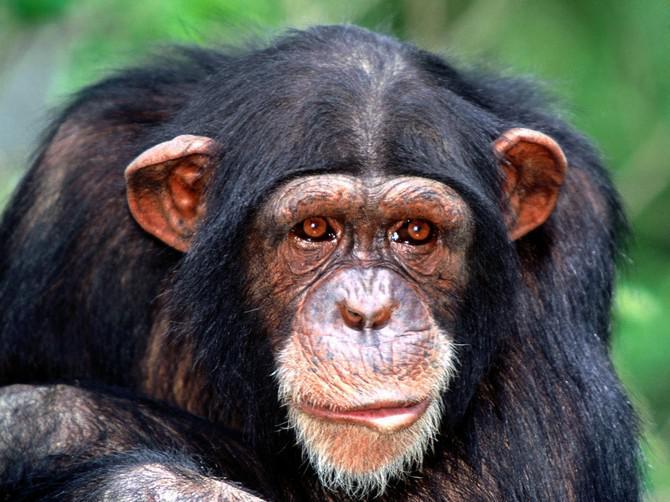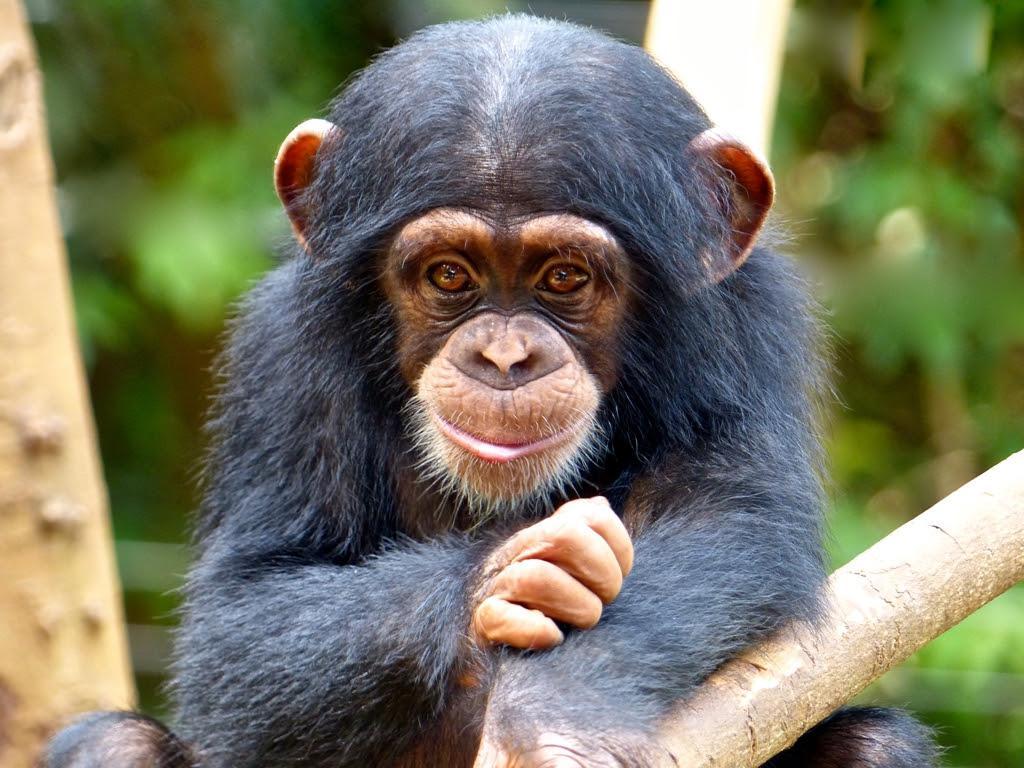The first image is the image on the left, the second image is the image on the right. Analyze the images presented: Is the assertion "In one of the images a baby monkey is cuddling its mother." valid? Answer yes or no. No. 